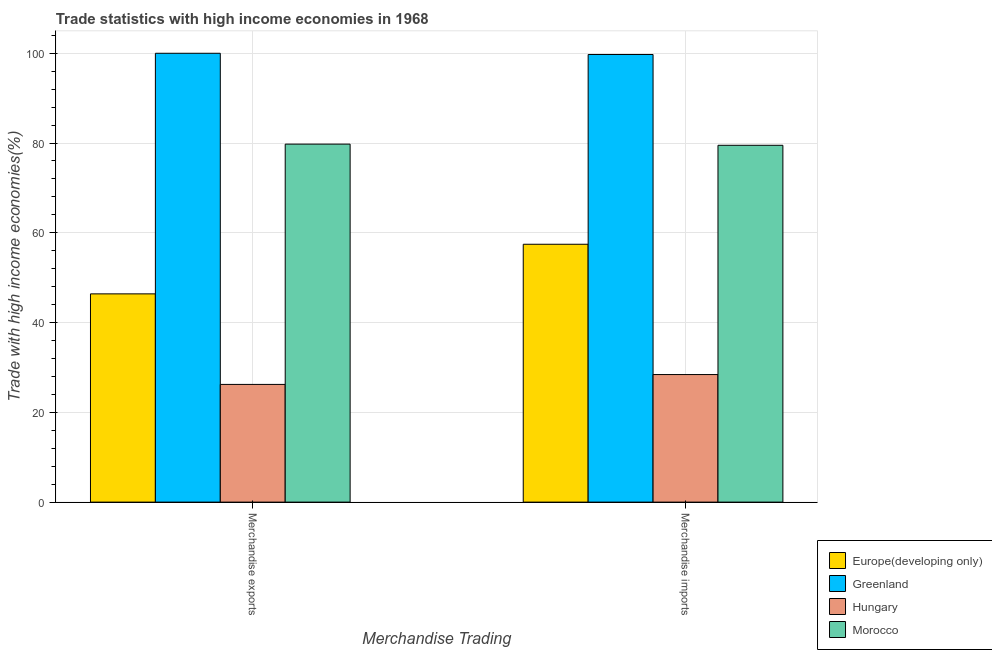How many different coloured bars are there?
Offer a very short reply. 4. Are the number of bars per tick equal to the number of legend labels?
Make the answer very short. Yes. How many bars are there on the 1st tick from the left?
Your answer should be very brief. 4. How many bars are there on the 2nd tick from the right?
Offer a terse response. 4. What is the label of the 2nd group of bars from the left?
Provide a succinct answer. Merchandise imports. What is the merchandise exports in Morocco?
Make the answer very short. 79.76. Across all countries, what is the minimum merchandise imports?
Ensure brevity in your answer.  28.42. In which country was the merchandise exports maximum?
Make the answer very short. Greenland. In which country was the merchandise exports minimum?
Provide a succinct answer. Hungary. What is the total merchandise imports in the graph?
Provide a short and direct response. 265.1. What is the difference between the merchandise exports in Greenland and that in Hungary?
Give a very brief answer. 73.78. What is the difference between the merchandise exports in Greenland and the merchandise imports in Europe(developing only)?
Your response must be concise. 42.55. What is the average merchandise exports per country?
Keep it short and to the point. 63.1. What is the difference between the merchandise imports and merchandise exports in Hungary?
Ensure brevity in your answer.  2.2. What is the ratio of the merchandise exports in Hungary to that in Greenland?
Offer a terse response. 0.26. What does the 3rd bar from the left in Merchandise imports represents?
Provide a succinct answer. Hungary. What does the 1st bar from the right in Merchandise imports represents?
Keep it short and to the point. Morocco. Are all the bars in the graph horizontal?
Give a very brief answer. No. How many countries are there in the graph?
Ensure brevity in your answer.  4. Are the values on the major ticks of Y-axis written in scientific E-notation?
Provide a succinct answer. No. Does the graph contain any zero values?
Your response must be concise. No. Does the graph contain grids?
Keep it short and to the point. Yes. How are the legend labels stacked?
Offer a very short reply. Vertical. What is the title of the graph?
Offer a very short reply. Trade statistics with high income economies in 1968. What is the label or title of the X-axis?
Keep it short and to the point. Merchandise Trading. What is the label or title of the Y-axis?
Your response must be concise. Trade with high income economies(%). What is the Trade with high income economies(%) of Europe(developing only) in Merchandise exports?
Make the answer very short. 46.4. What is the Trade with high income economies(%) in Hungary in Merchandise exports?
Offer a terse response. 26.22. What is the Trade with high income economies(%) of Morocco in Merchandise exports?
Your answer should be compact. 79.76. What is the Trade with high income economies(%) of Europe(developing only) in Merchandise imports?
Keep it short and to the point. 57.45. What is the Trade with high income economies(%) in Greenland in Merchandise imports?
Give a very brief answer. 99.73. What is the Trade with high income economies(%) in Hungary in Merchandise imports?
Provide a succinct answer. 28.42. What is the Trade with high income economies(%) of Morocco in Merchandise imports?
Keep it short and to the point. 79.5. Across all Merchandise Trading, what is the maximum Trade with high income economies(%) of Europe(developing only)?
Offer a very short reply. 57.45. Across all Merchandise Trading, what is the maximum Trade with high income economies(%) in Greenland?
Provide a short and direct response. 100. Across all Merchandise Trading, what is the maximum Trade with high income economies(%) in Hungary?
Your response must be concise. 28.42. Across all Merchandise Trading, what is the maximum Trade with high income economies(%) in Morocco?
Offer a very short reply. 79.76. Across all Merchandise Trading, what is the minimum Trade with high income economies(%) in Europe(developing only)?
Keep it short and to the point. 46.4. Across all Merchandise Trading, what is the minimum Trade with high income economies(%) in Greenland?
Make the answer very short. 99.73. Across all Merchandise Trading, what is the minimum Trade with high income economies(%) in Hungary?
Your answer should be very brief. 26.22. Across all Merchandise Trading, what is the minimum Trade with high income economies(%) of Morocco?
Your answer should be very brief. 79.5. What is the total Trade with high income economies(%) in Europe(developing only) in the graph?
Provide a short and direct response. 103.85. What is the total Trade with high income economies(%) of Greenland in the graph?
Provide a succinct answer. 199.73. What is the total Trade with high income economies(%) of Hungary in the graph?
Provide a succinct answer. 54.64. What is the total Trade with high income economies(%) in Morocco in the graph?
Ensure brevity in your answer.  159.26. What is the difference between the Trade with high income economies(%) of Europe(developing only) in Merchandise exports and that in Merchandise imports?
Your answer should be very brief. -11.05. What is the difference between the Trade with high income economies(%) of Greenland in Merchandise exports and that in Merchandise imports?
Your answer should be compact. 0.27. What is the difference between the Trade with high income economies(%) in Hungary in Merchandise exports and that in Merchandise imports?
Give a very brief answer. -2.2. What is the difference between the Trade with high income economies(%) in Morocco in Merchandise exports and that in Merchandise imports?
Your answer should be very brief. 0.26. What is the difference between the Trade with high income economies(%) in Europe(developing only) in Merchandise exports and the Trade with high income economies(%) in Greenland in Merchandise imports?
Provide a succinct answer. -53.33. What is the difference between the Trade with high income economies(%) in Europe(developing only) in Merchandise exports and the Trade with high income economies(%) in Hungary in Merchandise imports?
Offer a terse response. 17.98. What is the difference between the Trade with high income economies(%) of Europe(developing only) in Merchandise exports and the Trade with high income economies(%) of Morocco in Merchandise imports?
Make the answer very short. -33.1. What is the difference between the Trade with high income economies(%) in Greenland in Merchandise exports and the Trade with high income economies(%) in Hungary in Merchandise imports?
Provide a succinct answer. 71.58. What is the difference between the Trade with high income economies(%) of Greenland in Merchandise exports and the Trade with high income economies(%) of Morocco in Merchandise imports?
Keep it short and to the point. 20.5. What is the difference between the Trade with high income economies(%) in Hungary in Merchandise exports and the Trade with high income economies(%) in Morocco in Merchandise imports?
Provide a short and direct response. -53.28. What is the average Trade with high income economies(%) of Europe(developing only) per Merchandise Trading?
Keep it short and to the point. 51.92. What is the average Trade with high income economies(%) of Greenland per Merchandise Trading?
Keep it short and to the point. 99.86. What is the average Trade with high income economies(%) of Hungary per Merchandise Trading?
Make the answer very short. 27.32. What is the average Trade with high income economies(%) of Morocco per Merchandise Trading?
Offer a terse response. 79.63. What is the difference between the Trade with high income economies(%) in Europe(developing only) and Trade with high income economies(%) in Greenland in Merchandise exports?
Your answer should be very brief. -53.6. What is the difference between the Trade with high income economies(%) in Europe(developing only) and Trade with high income economies(%) in Hungary in Merchandise exports?
Your answer should be very brief. 20.17. What is the difference between the Trade with high income economies(%) in Europe(developing only) and Trade with high income economies(%) in Morocco in Merchandise exports?
Your answer should be compact. -33.36. What is the difference between the Trade with high income economies(%) in Greenland and Trade with high income economies(%) in Hungary in Merchandise exports?
Provide a short and direct response. 73.78. What is the difference between the Trade with high income economies(%) of Greenland and Trade with high income economies(%) of Morocco in Merchandise exports?
Your response must be concise. 20.24. What is the difference between the Trade with high income economies(%) in Hungary and Trade with high income economies(%) in Morocco in Merchandise exports?
Provide a succinct answer. -53.54. What is the difference between the Trade with high income economies(%) of Europe(developing only) and Trade with high income economies(%) of Greenland in Merchandise imports?
Give a very brief answer. -42.28. What is the difference between the Trade with high income economies(%) in Europe(developing only) and Trade with high income economies(%) in Hungary in Merchandise imports?
Provide a succinct answer. 29.03. What is the difference between the Trade with high income economies(%) of Europe(developing only) and Trade with high income economies(%) of Morocco in Merchandise imports?
Your answer should be very brief. -22.05. What is the difference between the Trade with high income economies(%) of Greenland and Trade with high income economies(%) of Hungary in Merchandise imports?
Your answer should be compact. 71.31. What is the difference between the Trade with high income economies(%) of Greenland and Trade with high income economies(%) of Morocco in Merchandise imports?
Make the answer very short. 20.23. What is the difference between the Trade with high income economies(%) in Hungary and Trade with high income economies(%) in Morocco in Merchandise imports?
Ensure brevity in your answer.  -51.08. What is the ratio of the Trade with high income economies(%) in Europe(developing only) in Merchandise exports to that in Merchandise imports?
Provide a succinct answer. 0.81. What is the ratio of the Trade with high income economies(%) of Hungary in Merchandise exports to that in Merchandise imports?
Give a very brief answer. 0.92. What is the difference between the highest and the second highest Trade with high income economies(%) of Europe(developing only)?
Provide a succinct answer. 11.05. What is the difference between the highest and the second highest Trade with high income economies(%) of Greenland?
Provide a succinct answer. 0.27. What is the difference between the highest and the second highest Trade with high income economies(%) in Hungary?
Ensure brevity in your answer.  2.2. What is the difference between the highest and the second highest Trade with high income economies(%) of Morocco?
Your answer should be very brief. 0.26. What is the difference between the highest and the lowest Trade with high income economies(%) in Europe(developing only)?
Ensure brevity in your answer.  11.05. What is the difference between the highest and the lowest Trade with high income economies(%) in Greenland?
Give a very brief answer. 0.27. What is the difference between the highest and the lowest Trade with high income economies(%) of Hungary?
Provide a short and direct response. 2.2. What is the difference between the highest and the lowest Trade with high income economies(%) of Morocco?
Provide a short and direct response. 0.26. 